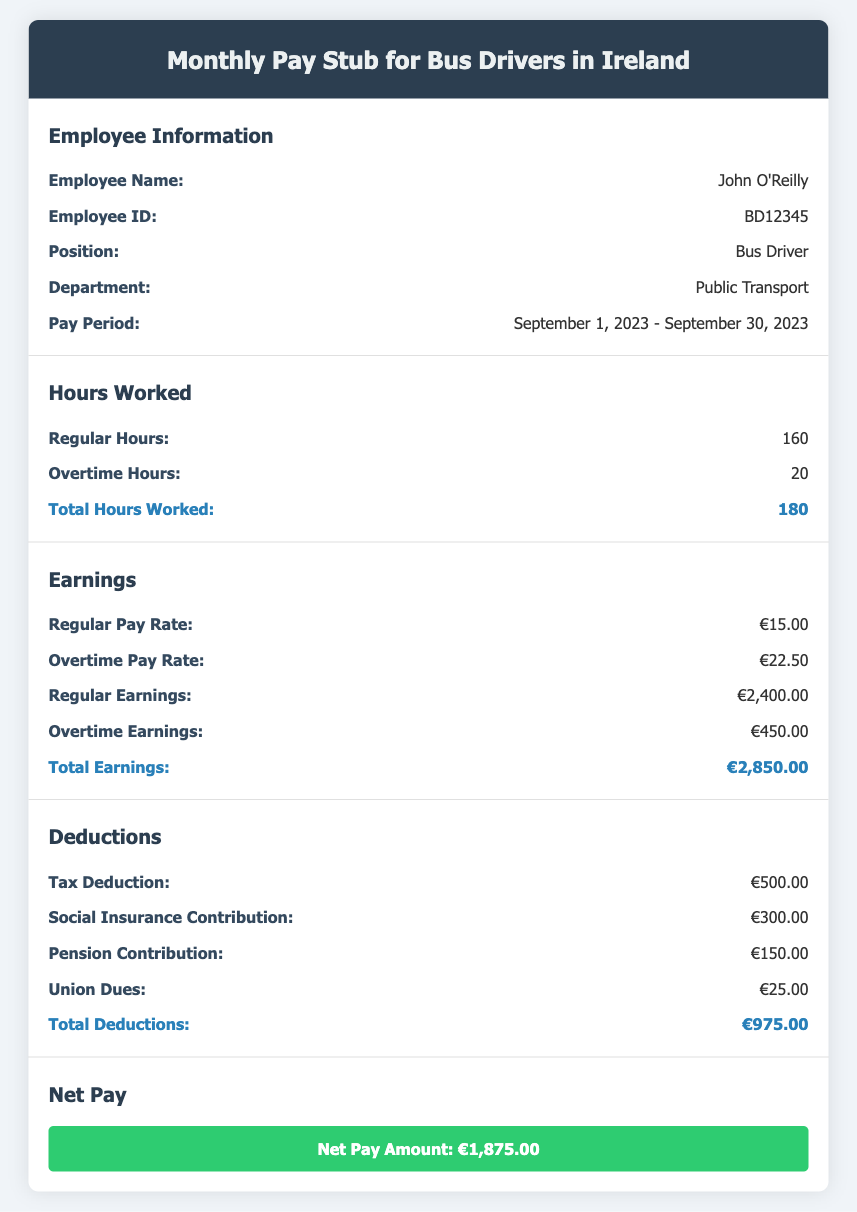What is the employee's name? The employee's name is specified in the document under Employee Information.
Answer: John O'Reilly How many regular hours were worked? The regular hours worked are stated in the Hours Worked section of the document.
Answer: 160 What is the overtime pay rate? The overtime pay rate is found in the Earnings section of the document.
Answer: €22.50 What is the total deductions amount? The total deductions amount is calculated and presented in the Deductions section of the document.
Answer: €975.00 What is the net pay amount? The net pay amount is the final figure presented in the Net Pay section of the document.
Answer: €1,875.00 How many total hours were worked? The total hours worked are calculated by adding regular and overtime hours in the Hours Worked section.
Answer: 180 What is the regular pay rate? The regular pay rate is listed in the Earnings section of the document.
Answer: €15.00 What is the total earnings amount? The total earnings amount is the sum of regular and overtime earnings reported in the Earnings section.
Answer: €2,850.00 What is the employee's position? The employee's position is indicated under Employee Information in the document.
Answer: Bus Driver What was the pay period? The pay period is specified under Employee Information in the document.
Answer: September 1, 2023 - September 30, 2023 